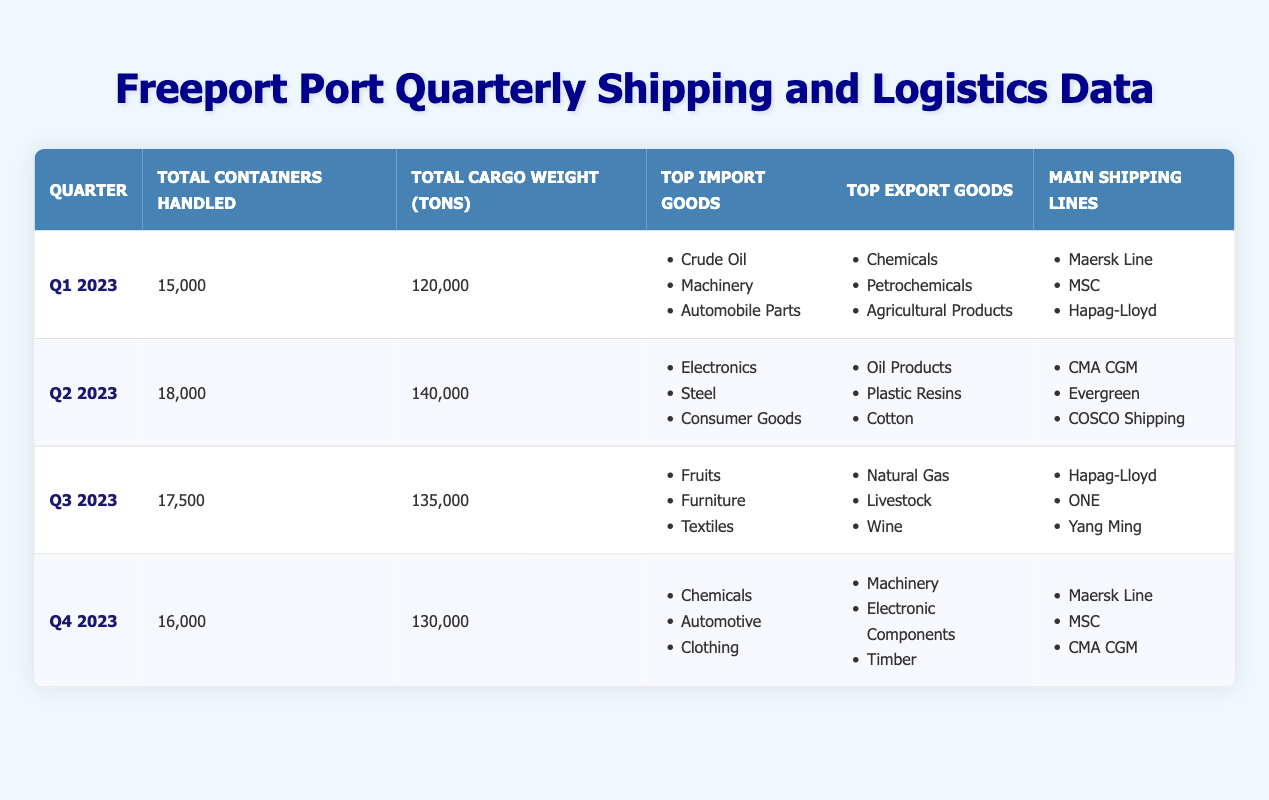What was the total cargo weight handled in Q2 2023? In the table, under the column for Q2 2023, the Total Cargo Weight (Tons) is listed as 140,000.
Answer: 140,000 Which quarter had the highest number of total containers handled? By checking the Total Containers Handled column, Q2 2023 has the highest value at 18,000 compared to other quarters (Q1: 15,000, Q3: 17,500, Q4: 16,000).
Answer: Q2 2023 Was "Automobile Parts" listed as a top import good in any quarter? Looking through the Top Import Goods in each quarter, "Automobile Parts" appears only in Q1 2023 as one of the top three import goods.
Answer: Yes What is the average total cargo weight handled across all quarters? We collect the Total Cargo Weight values: 120,000 (Q1) + 140,000 (Q2) + 135,000 (Q3) + 130,000 (Q4) = 525,000. There are 4 data points, so the average is 525,000 / 4 = 131,250.
Answer: 131,250 Which shipping line appears in both Q1 and Q4 as a main shipping line? By checking the Main Shipping Lines rows for Q1 and Q4, "Maersk Line" and "MSC" appear in both quarters, confirming they are common.
Answer: Maersk Line and MSC How many different types of goods were the top imports and exports across Q1 to Q4? By combining all unique entries from Top Import Goods and Top Export Goods: (Crude Oil, Machinery, Automobile Parts, Electronics, Steel, Consumer Goods, Fruits, Furniture, Textiles, Chemicals, Automotive, Clothing, Oil Products, Plastic Resins, Cotton, Natural Gas, Livestock, Wine, Machinery, Electronic Components, Timber). There are 20 unique goods in total.
Answer: 20 Did any quarter see an increased number of total containers handled from the previous quarter? Q2 2023 saw an increase from Q1 (15,000 to 18,000), while Q3 decreased from Q2 (18,000 to 17,500), and Q4 decreased again to 16,000, confirming only Q2 had an increase.
Answer: Yes What was the total weight of cargo handled in Q3 2023 compared to Q1 2023? The Total Cargo Weight for Q3 2023 is 135,000 and for Q1 2023 is 120,000. Thus, the weight for Q3 is higher by 15,000 tons (135,000 - 120,000).
Answer: 15,000 tons more in Q3 2023 